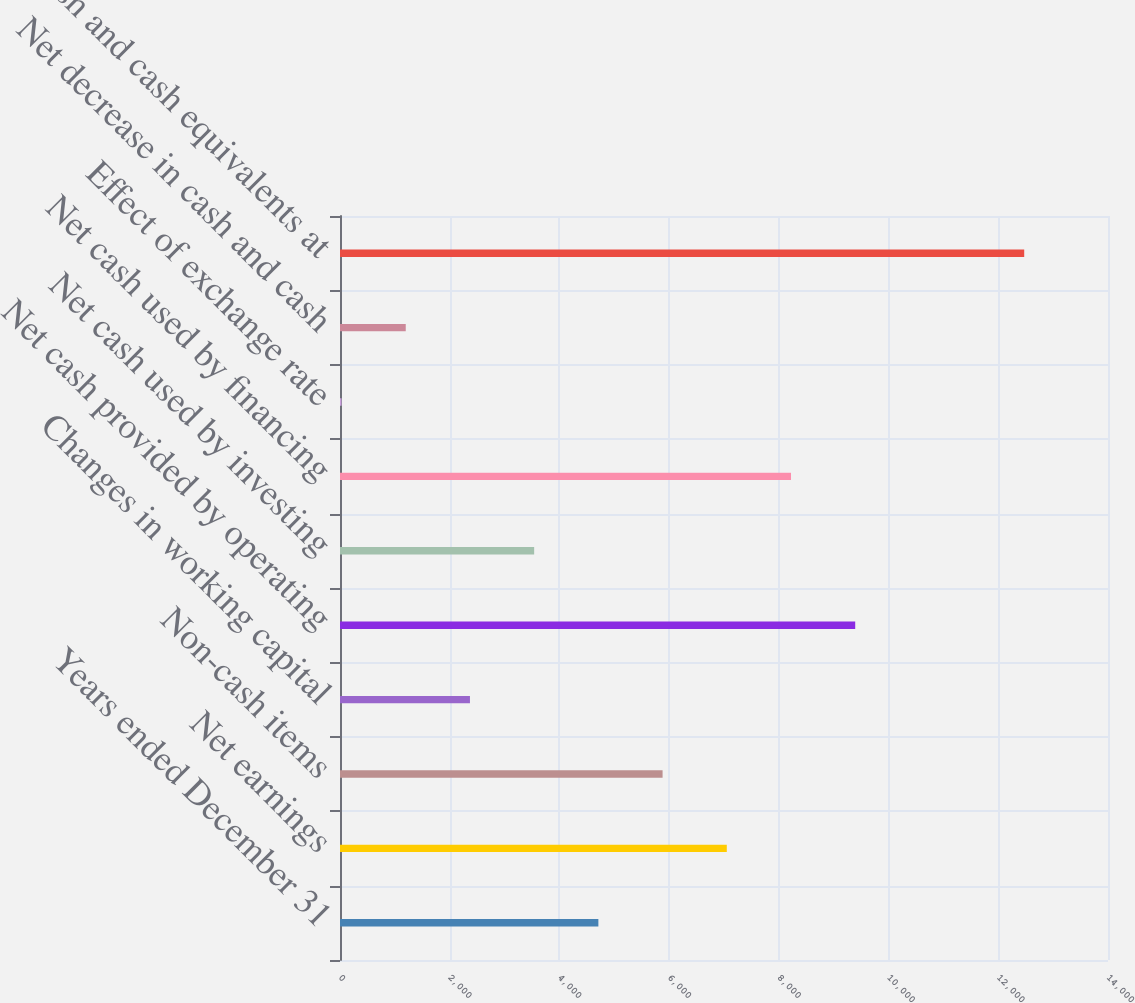Convert chart to OTSL. <chart><loc_0><loc_0><loc_500><loc_500><bar_chart><fcel>Years ended December 31<fcel>Net earnings<fcel>Non-cash items<fcel>Changes in working capital<fcel>Net cash provided by operating<fcel>Net cash used by investing<fcel>Net cash used by financing<fcel>Effect of exchange rate<fcel>Net decrease in cash and cash<fcel>Cash and cash equivalents at<nl><fcel>4710<fcel>7051<fcel>5880.5<fcel>2369<fcel>9392<fcel>3539.5<fcel>8221.5<fcel>28<fcel>1198.5<fcel>12472.5<nl></chart> 